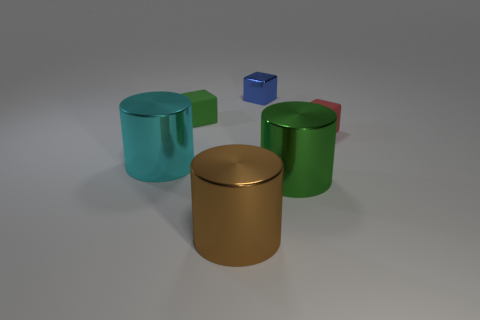Can you describe the textures that are visible on the objects in this image? Certainly! The objects exhibit a smooth, matte texture with subtle reflections indicating a non-glossy surface finish, which suggests they might be made of materials such as plastic or painted metal. 